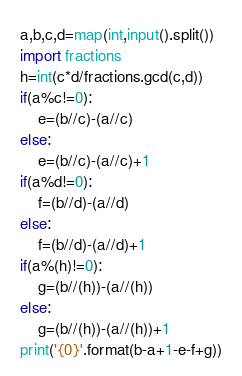Convert code to text. <code><loc_0><loc_0><loc_500><loc_500><_Python_>a,b,c,d=map(int,input().split())
import fractions
h=int(c*d/fractions.gcd(c,d))
if(a%c!=0):
    e=(b//c)-(a//c)
else:
    e=(b//c)-(a//c)+1
if(a%d!=0):
    f=(b//d)-(a//d)
else:
    f=(b//d)-(a//d)+1
if(a%(h)!=0):
    g=(b//(h))-(a//(h))
else:
    g=(b//(h))-(a//(h))+1
print('{0}'.format(b-a+1-e-f+g))
</code> 